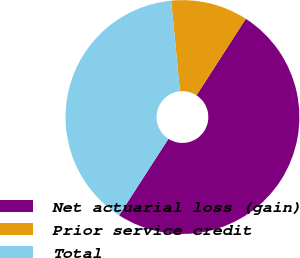Convert chart to OTSL. <chart><loc_0><loc_0><loc_500><loc_500><pie_chart><fcel>Net actuarial loss (gain)<fcel>Prior service credit<fcel>Total<nl><fcel>50.0%<fcel>10.65%<fcel>39.35%<nl></chart> 